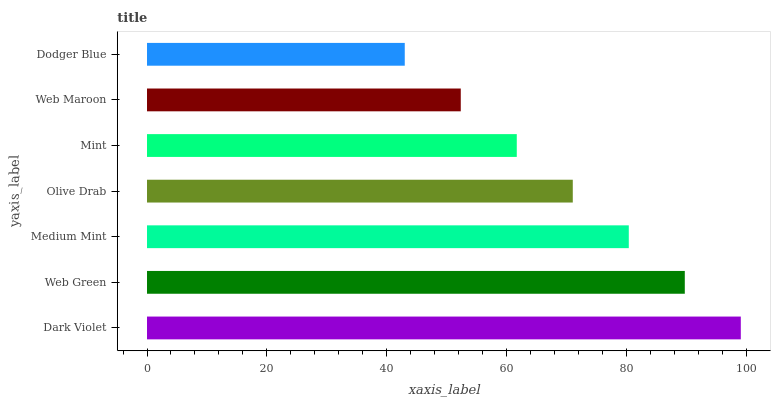Is Dodger Blue the minimum?
Answer yes or no. Yes. Is Dark Violet the maximum?
Answer yes or no. Yes. Is Web Green the minimum?
Answer yes or no. No. Is Web Green the maximum?
Answer yes or no. No. Is Dark Violet greater than Web Green?
Answer yes or no. Yes. Is Web Green less than Dark Violet?
Answer yes or no. Yes. Is Web Green greater than Dark Violet?
Answer yes or no. No. Is Dark Violet less than Web Green?
Answer yes or no. No. Is Olive Drab the high median?
Answer yes or no. Yes. Is Olive Drab the low median?
Answer yes or no. Yes. Is Dodger Blue the high median?
Answer yes or no. No. Is Web Green the low median?
Answer yes or no. No. 